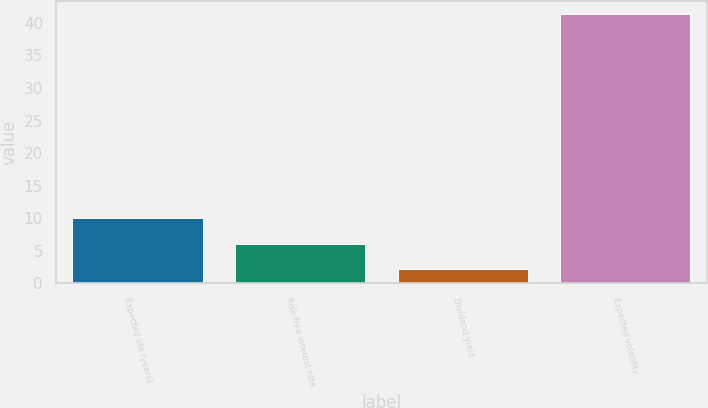<chart> <loc_0><loc_0><loc_500><loc_500><bar_chart><fcel>Expected life (years)<fcel>Risk-free interest rate<fcel>Dividend yield<fcel>Expected volatility<nl><fcel>10.02<fcel>6.11<fcel>2.2<fcel>41.3<nl></chart> 